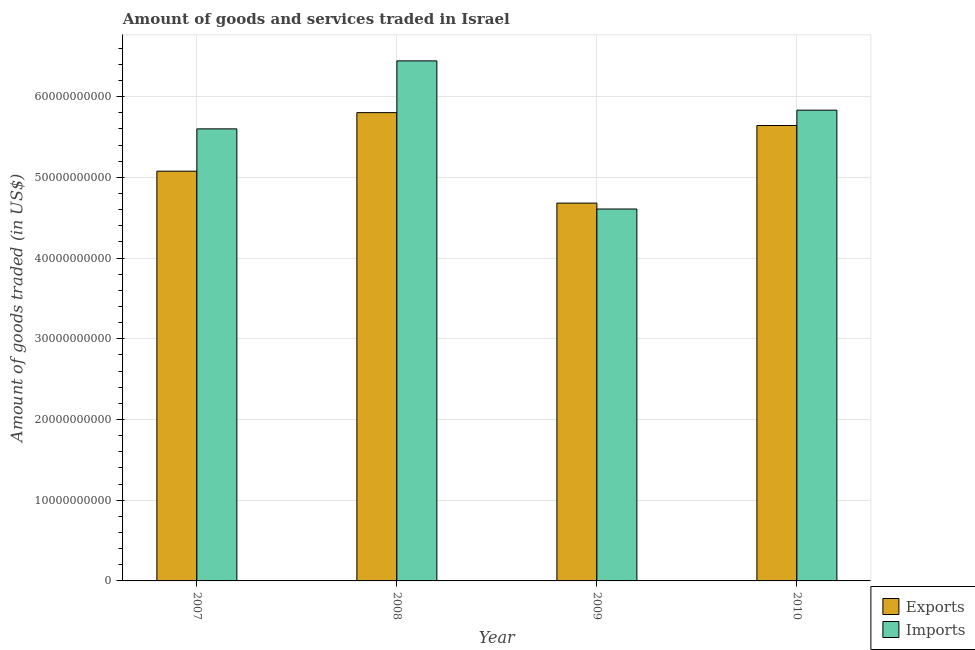How many groups of bars are there?
Provide a succinct answer. 4. What is the amount of goods exported in 2007?
Offer a very short reply. 5.08e+1. Across all years, what is the maximum amount of goods exported?
Your answer should be compact. 5.80e+1. Across all years, what is the minimum amount of goods imported?
Your response must be concise. 4.61e+1. In which year was the amount of goods imported minimum?
Your response must be concise. 2009. What is the total amount of goods exported in the graph?
Your response must be concise. 2.12e+11. What is the difference between the amount of goods imported in 2007 and that in 2009?
Provide a succinct answer. 9.93e+09. What is the difference between the amount of goods exported in 2009 and the amount of goods imported in 2007?
Your answer should be very brief. -3.95e+09. What is the average amount of goods exported per year?
Make the answer very short. 5.30e+1. In the year 2007, what is the difference between the amount of goods imported and amount of goods exported?
Make the answer very short. 0. What is the ratio of the amount of goods exported in 2007 to that in 2010?
Offer a terse response. 0.9. What is the difference between the highest and the second highest amount of goods imported?
Your response must be concise. 6.11e+09. What is the difference between the highest and the lowest amount of goods exported?
Ensure brevity in your answer.  1.12e+1. Is the sum of the amount of goods imported in 2007 and 2010 greater than the maximum amount of goods exported across all years?
Provide a short and direct response. Yes. What does the 1st bar from the left in 2010 represents?
Keep it short and to the point. Exports. What does the 1st bar from the right in 2010 represents?
Your answer should be compact. Imports. Are all the bars in the graph horizontal?
Keep it short and to the point. No. What is the difference between two consecutive major ticks on the Y-axis?
Offer a terse response. 1.00e+1. Are the values on the major ticks of Y-axis written in scientific E-notation?
Offer a terse response. No. Does the graph contain any zero values?
Provide a succinct answer. No. Does the graph contain grids?
Offer a very short reply. Yes. Where does the legend appear in the graph?
Give a very brief answer. Bottom right. What is the title of the graph?
Give a very brief answer. Amount of goods and services traded in Israel. Does "Manufacturing industries and construction" appear as one of the legend labels in the graph?
Make the answer very short. No. What is the label or title of the Y-axis?
Ensure brevity in your answer.  Amount of goods traded (in US$). What is the Amount of goods traded (in US$) of Exports in 2007?
Offer a terse response. 5.08e+1. What is the Amount of goods traded (in US$) in Imports in 2007?
Your answer should be compact. 5.60e+1. What is the Amount of goods traded (in US$) of Exports in 2008?
Give a very brief answer. 5.80e+1. What is the Amount of goods traded (in US$) in Imports in 2008?
Ensure brevity in your answer.  6.44e+1. What is the Amount of goods traded (in US$) of Exports in 2009?
Your response must be concise. 4.68e+1. What is the Amount of goods traded (in US$) in Imports in 2009?
Your answer should be compact. 4.61e+1. What is the Amount of goods traded (in US$) in Exports in 2010?
Your response must be concise. 5.64e+1. What is the Amount of goods traded (in US$) of Imports in 2010?
Your answer should be compact. 5.83e+1. Across all years, what is the maximum Amount of goods traded (in US$) of Exports?
Give a very brief answer. 5.80e+1. Across all years, what is the maximum Amount of goods traded (in US$) of Imports?
Provide a short and direct response. 6.44e+1. Across all years, what is the minimum Amount of goods traded (in US$) of Exports?
Ensure brevity in your answer.  4.68e+1. Across all years, what is the minimum Amount of goods traded (in US$) of Imports?
Your answer should be very brief. 4.61e+1. What is the total Amount of goods traded (in US$) of Exports in the graph?
Give a very brief answer. 2.12e+11. What is the total Amount of goods traded (in US$) in Imports in the graph?
Your response must be concise. 2.25e+11. What is the difference between the Amount of goods traded (in US$) in Exports in 2007 and that in 2008?
Offer a very short reply. -7.25e+09. What is the difference between the Amount of goods traded (in US$) in Imports in 2007 and that in 2008?
Your response must be concise. -8.42e+09. What is the difference between the Amount of goods traded (in US$) in Exports in 2007 and that in 2009?
Your response must be concise. 3.95e+09. What is the difference between the Amount of goods traded (in US$) in Imports in 2007 and that in 2009?
Your answer should be compact. 9.93e+09. What is the difference between the Amount of goods traded (in US$) in Exports in 2007 and that in 2010?
Keep it short and to the point. -5.66e+09. What is the difference between the Amount of goods traded (in US$) in Imports in 2007 and that in 2010?
Keep it short and to the point. -2.32e+09. What is the difference between the Amount of goods traded (in US$) in Exports in 2008 and that in 2009?
Offer a terse response. 1.12e+1. What is the difference between the Amount of goods traded (in US$) in Imports in 2008 and that in 2009?
Ensure brevity in your answer.  1.84e+1. What is the difference between the Amount of goods traded (in US$) in Exports in 2008 and that in 2010?
Keep it short and to the point. 1.60e+09. What is the difference between the Amount of goods traded (in US$) in Imports in 2008 and that in 2010?
Your answer should be very brief. 6.11e+09. What is the difference between the Amount of goods traded (in US$) of Exports in 2009 and that in 2010?
Your answer should be compact. -9.61e+09. What is the difference between the Amount of goods traded (in US$) of Imports in 2009 and that in 2010?
Provide a short and direct response. -1.22e+1. What is the difference between the Amount of goods traded (in US$) in Exports in 2007 and the Amount of goods traded (in US$) in Imports in 2008?
Ensure brevity in your answer.  -1.37e+1. What is the difference between the Amount of goods traded (in US$) in Exports in 2007 and the Amount of goods traded (in US$) in Imports in 2009?
Keep it short and to the point. 4.69e+09. What is the difference between the Amount of goods traded (in US$) in Exports in 2007 and the Amount of goods traded (in US$) in Imports in 2010?
Offer a very short reply. -7.56e+09. What is the difference between the Amount of goods traded (in US$) in Exports in 2008 and the Amount of goods traded (in US$) in Imports in 2009?
Your answer should be compact. 1.19e+1. What is the difference between the Amount of goods traded (in US$) in Exports in 2008 and the Amount of goods traded (in US$) in Imports in 2010?
Keep it short and to the point. -3.05e+08. What is the difference between the Amount of goods traded (in US$) of Exports in 2009 and the Amount of goods traded (in US$) of Imports in 2010?
Provide a short and direct response. -1.15e+1. What is the average Amount of goods traded (in US$) in Exports per year?
Offer a terse response. 5.30e+1. What is the average Amount of goods traded (in US$) of Imports per year?
Provide a succinct answer. 5.62e+1. In the year 2007, what is the difference between the Amount of goods traded (in US$) in Exports and Amount of goods traded (in US$) in Imports?
Offer a very short reply. -5.24e+09. In the year 2008, what is the difference between the Amount of goods traded (in US$) of Exports and Amount of goods traded (in US$) of Imports?
Ensure brevity in your answer.  -6.41e+09. In the year 2009, what is the difference between the Amount of goods traded (in US$) of Exports and Amount of goods traded (in US$) of Imports?
Offer a terse response. 7.33e+08. In the year 2010, what is the difference between the Amount of goods traded (in US$) in Exports and Amount of goods traded (in US$) in Imports?
Make the answer very short. -1.90e+09. What is the ratio of the Amount of goods traded (in US$) in Imports in 2007 to that in 2008?
Give a very brief answer. 0.87. What is the ratio of the Amount of goods traded (in US$) in Exports in 2007 to that in 2009?
Make the answer very short. 1.08. What is the ratio of the Amount of goods traded (in US$) in Imports in 2007 to that in 2009?
Make the answer very short. 1.22. What is the ratio of the Amount of goods traded (in US$) of Exports in 2007 to that in 2010?
Your answer should be very brief. 0.9. What is the ratio of the Amount of goods traded (in US$) of Imports in 2007 to that in 2010?
Offer a terse response. 0.96. What is the ratio of the Amount of goods traded (in US$) of Exports in 2008 to that in 2009?
Your answer should be very brief. 1.24. What is the ratio of the Amount of goods traded (in US$) in Imports in 2008 to that in 2009?
Offer a very short reply. 1.4. What is the ratio of the Amount of goods traded (in US$) of Exports in 2008 to that in 2010?
Your answer should be compact. 1.03. What is the ratio of the Amount of goods traded (in US$) in Imports in 2008 to that in 2010?
Your answer should be very brief. 1.1. What is the ratio of the Amount of goods traded (in US$) of Exports in 2009 to that in 2010?
Provide a succinct answer. 0.83. What is the ratio of the Amount of goods traded (in US$) in Imports in 2009 to that in 2010?
Your answer should be compact. 0.79. What is the difference between the highest and the second highest Amount of goods traded (in US$) in Exports?
Give a very brief answer. 1.60e+09. What is the difference between the highest and the second highest Amount of goods traded (in US$) of Imports?
Give a very brief answer. 6.11e+09. What is the difference between the highest and the lowest Amount of goods traded (in US$) in Exports?
Your response must be concise. 1.12e+1. What is the difference between the highest and the lowest Amount of goods traded (in US$) in Imports?
Ensure brevity in your answer.  1.84e+1. 